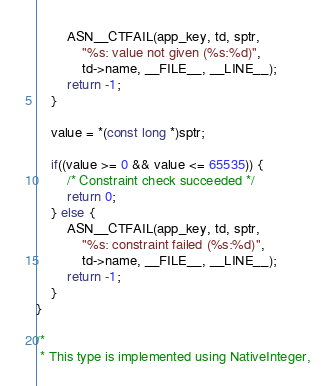<code> <loc_0><loc_0><loc_500><loc_500><_C_>		ASN__CTFAIL(app_key, td, sptr,
			"%s: value not given (%s:%d)",
			td->name, __FILE__, __LINE__);
		return -1;
	}
	
	value = *(const long *)sptr;
	
	if((value >= 0 && value <= 65535)) {
		/* Constraint check succeeded */
		return 0;
	} else {
		ASN__CTFAIL(app_key, td, sptr,
			"%s: constraint failed (%s:%d)",
			td->name, __FILE__, __LINE__);
		return -1;
	}
}

/*
 * This type is implemented using NativeInteger,</code> 